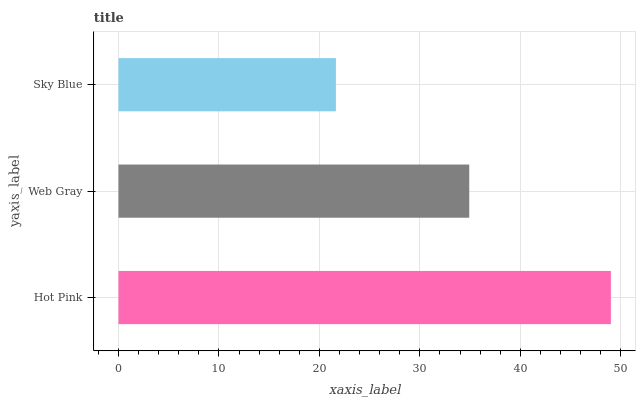Is Sky Blue the minimum?
Answer yes or no. Yes. Is Hot Pink the maximum?
Answer yes or no. Yes. Is Web Gray the minimum?
Answer yes or no. No. Is Web Gray the maximum?
Answer yes or no. No. Is Hot Pink greater than Web Gray?
Answer yes or no. Yes. Is Web Gray less than Hot Pink?
Answer yes or no. Yes. Is Web Gray greater than Hot Pink?
Answer yes or no. No. Is Hot Pink less than Web Gray?
Answer yes or no. No. Is Web Gray the high median?
Answer yes or no. Yes. Is Web Gray the low median?
Answer yes or no. Yes. Is Hot Pink the high median?
Answer yes or no. No. Is Hot Pink the low median?
Answer yes or no. No. 